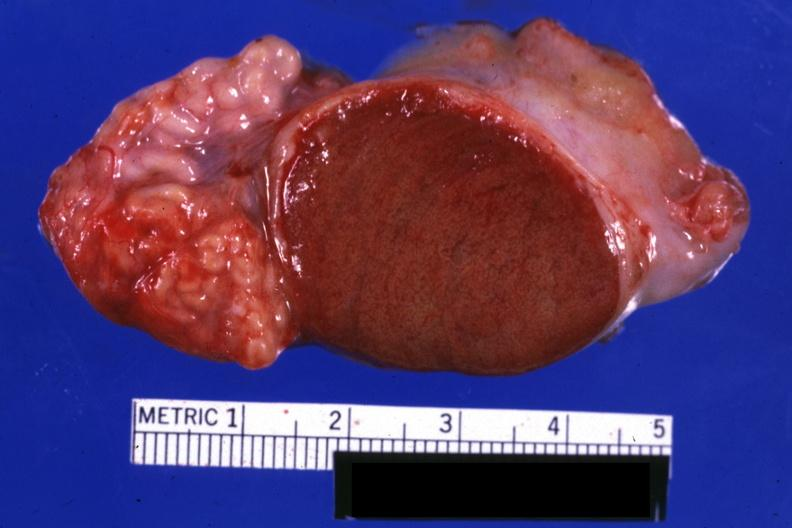s excellent close-up view sliced open testicle with intact epididymis?
Answer the question using a single word or phrase. Yes 